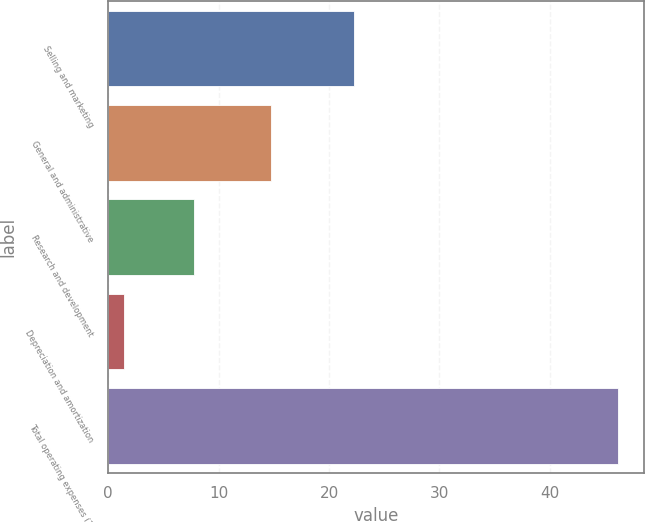<chart> <loc_0><loc_0><loc_500><loc_500><bar_chart><fcel>Selling and marketing<fcel>General and administrative<fcel>Research and development<fcel>Depreciation and amortization<fcel>Total operating expenses (1)<nl><fcel>22.3<fcel>14.7<fcel>7.8<fcel>1.4<fcel>46.2<nl></chart> 